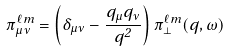Convert formula to latex. <formula><loc_0><loc_0><loc_500><loc_500>\pi _ { \mu \nu } ^ { \ell m } = \left ( \delta _ { \mu \nu } - \frac { q _ { \mu } q _ { \nu } } { q ^ { 2 } } \right ) \pi _ { \perp } ^ { \ell m } ( q , \omega )</formula> 